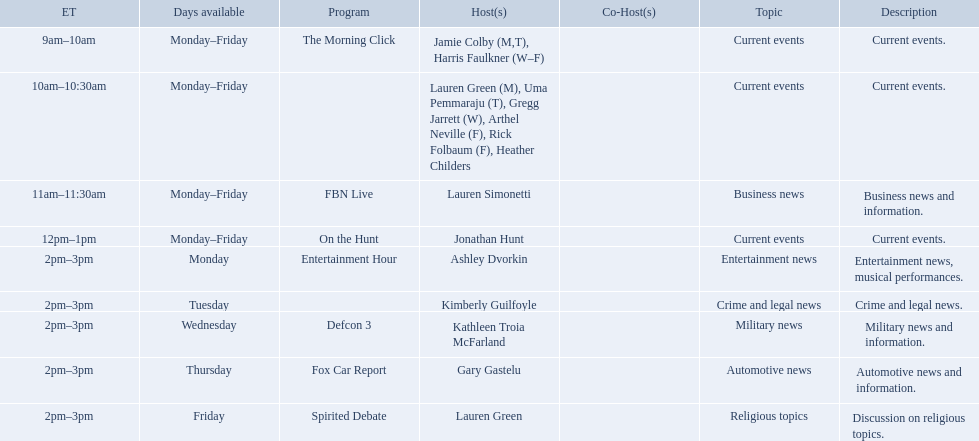Which programs broadcast by fox news channel hosts are listed? Jamie Colby (M,T), Harris Faulkner (W–F), Lauren Green (M), Uma Pemmaraju (T), Gregg Jarrett (W), Arthel Neville (F), Rick Folbaum (F), Heather Childers, Lauren Simonetti, Jonathan Hunt, Ashley Dvorkin, Kimberly Guilfoyle, Kathleen Troia McFarland, Gary Gastelu, Lauren Green. Of those, who have shows on friday? Jamie Colby (M,T), Harris Faulkner (W–F), Lauren Green (M), Uma Pemmaraju (T), Gregg Jarrett (W), Arthel Neville (F), Rick Folbaum (F), Heather Childers, Lauren Simonetti, Jonathan Hunt, Lauren Green. Of those, whose is at 2 pm? Lauren Green. 